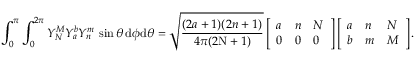Convert formula to latex. <formula><loc_0><loc_0><loc_500><loc_500>\int _ { 0 } ^ { \pi } \int _ { 0 } ^ { 2 \pi } Y _ { N } ^ { M } Y _ { a } ^ { b } Y _ { n } ^ { m } \, \sin \theta \, d \phi d \theta = \sqrt { \frac { ( 2 a + 1 ) ( 2 n + 1 ) } { 4 \pi ( 2 N + 1 ) } } \left [ \begin{array} { l l l } { a } & { n } & { N } \\ { 0 } & { 0 } & { 0 } \end{array} \right ] \left [ \begin{array} { l l l } { a } & { n } & { N } \\ { b } & { m } & { M } \end{array} \right ] .</formula> 